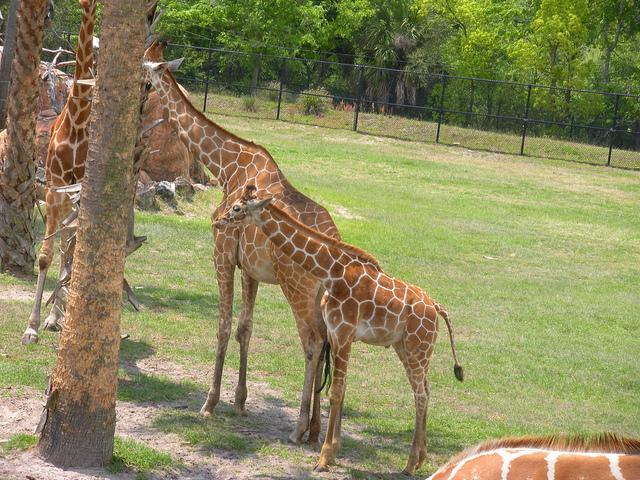Why are the animals enclosed in one area?

Choices:
A) to protect
B) to hunt
C) to capture
D) to heal to protect 